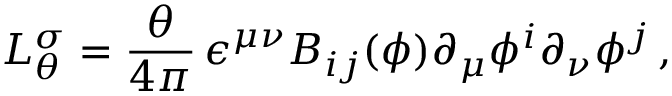<formula> <loc_0><loc_0><loc_500><loc_500>L _ { \theta } ^ { \sigma } = { \frac { \theta } { 4 \pi } } \, \epsilon ^ { \mu \nu } B _ { i j } ( \phi ) \partial _ { \mu } \phi ^ { i } \partial _ { \nu } \phi ^ { j } \, ,</formula> 